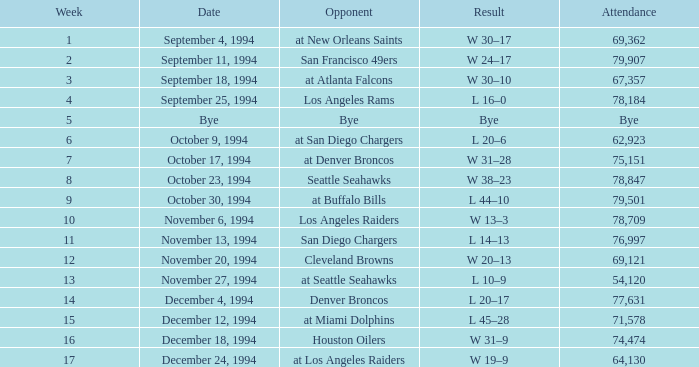What was the points tally in the chiefs' game on november 27, 1994? L 10–9. 